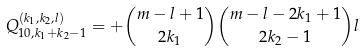Convert formula to latex. <formula><loc_0><loc_0><loc_500><loc_500>Q _ { 1 0 , k _ { 1 } + k _ { 2 } - 1 } ^ { ( k _ { 1 } , k _ { 2 } , l ) } = + { m - l + 1 \choose 2 k _ { 1 } } { m - l - 2 k _ { 1 } + 1 \choose 2 k _ { 2 } - 1 } l</formula> 